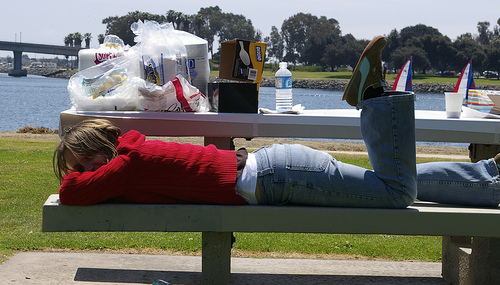<image>
Can you confirm if the car is behind the concrete? Yes. From this viewpoint, the car is positioned behind the concrete, with the concrete partially or fully occluding the car. Where is the girl in relation to the bench? Is it on the bench? Yes. Looking at the image, I can see the girl is positioned on top of the bench, with the bench providing support. Is there a person on the grass? No. The person is not positioned on the grass. They may be near each other, but the person is not supported by or resting on top of the grass. 